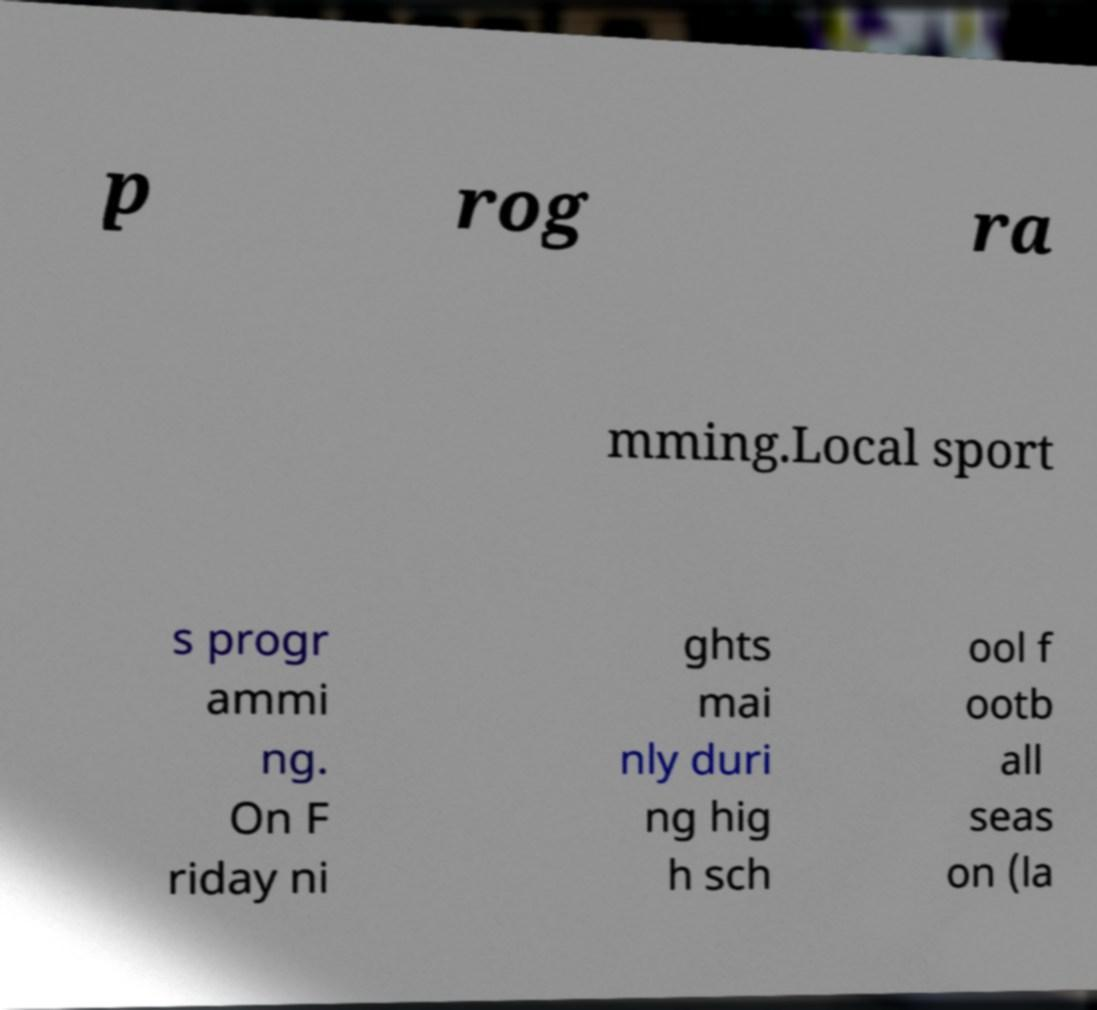I need the written content from this picture converted into text. Can you do that? p rog ra mming.Local sport s progr ammi ng. On F riday ni ghts mai nly duri ng hig h sch ool f ootb all seas on (la 